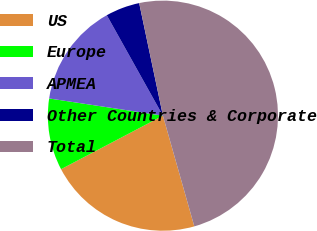Convert chart to OTSL. <chart><loc_0><loc_0><loc_500><loc_500><pie_chart><fcel>US<fcel>Europe<fcel>APMEA<fcel>Other Countries & Corporate<fcel>Total<nl><fcel>21.7%<fcel>10.09%<fcel>14.5%<fcel>4.8%<fcel>48.91%<nl></chart> 